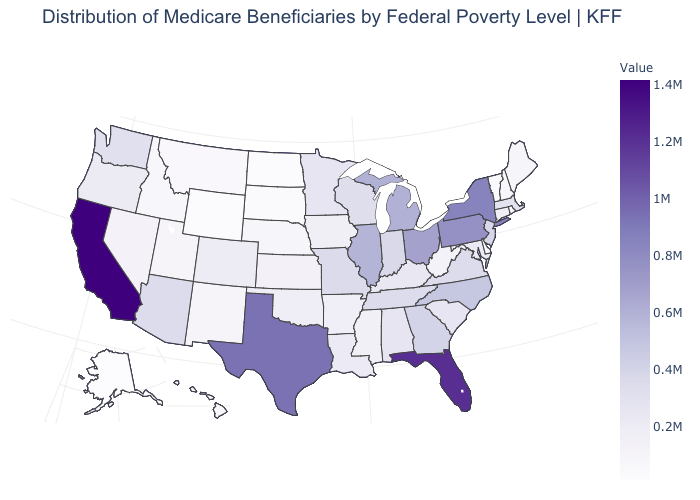Which states have the lowest value in the USA?
Answer briefly. Alaska. Is the legend a continuous bar?
Answer briefly. Yes. Does Ohio have a lower value than Nevada?
Write a very short answer. No. Does California have the highest value in the USA?
Be succinct. Yes. Which states hav the highest value in the West?
Short answer required. California. Does Alaska have the lowest value in the West?
Write a very short answer. Yes. Is the legend a continuous bar?
Be succinct. Yes. Among the states that border Georgia , does South Carolina have the lowest value?
Give a very brief answer. Yes. Does Delaware have the lowest value in the South?
Write a very short answer. Yes. 